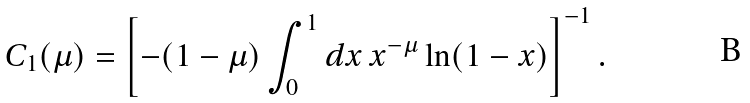Convert formula to latex. <formula><loc_0><loc_0><loc_500><loc_500>C _ { 1 } ( \mu ) = \left [ - ( 1 - \mu ) \int _ { 0 } ^ { 1 } d x \, x ^ { - \mu } \ln ( 1 - x ) \right ] ^ { - 1 } .</formula> 